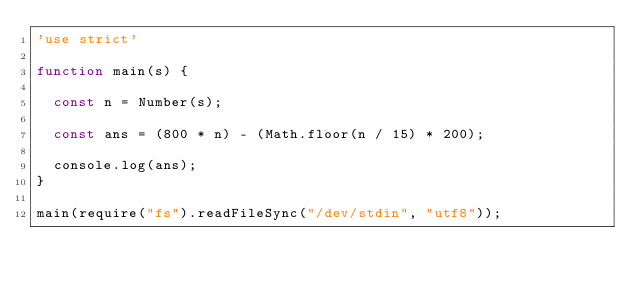Convert code to text. <code><loc_0><loc_0><loc_500><loc_500><_JavaScript_>'use strict'

function main(s) {

  const n = Number(s);

  const ans = (800 * n) - (Math.floor(n / 15) * 200);

  console.log(ans);
}

main(require("fs").readFileSync("/dev/stdin", "utf8"));
</code> 